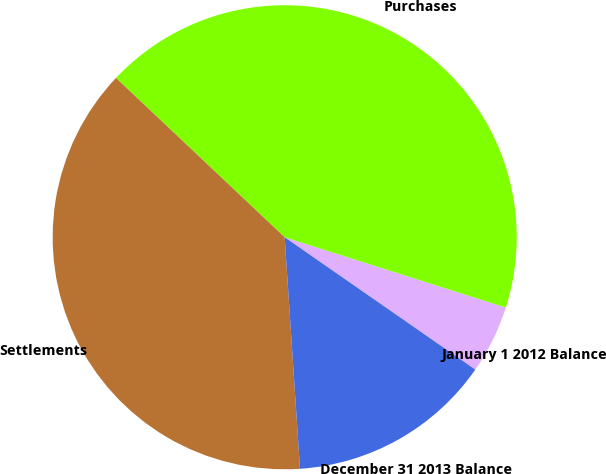Convert chart. <chart><loc_0><loc_0><loc_500><loc_500><pie_chart><fcel>January 1 2012 Balance<fcel>Purchases<fcel>Settlements<fcel>December 31 2013 Balance<nl><fcel>4.76%<fcel>42.86%<fcel>38.1%<fcel>14.29%<nl></chart> 